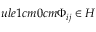<formula> <loc_0><loc_0><loc_500><loc_500>u l e { 1 c m } { 0 c m } \Phi _ { i j } \in H</formula> 